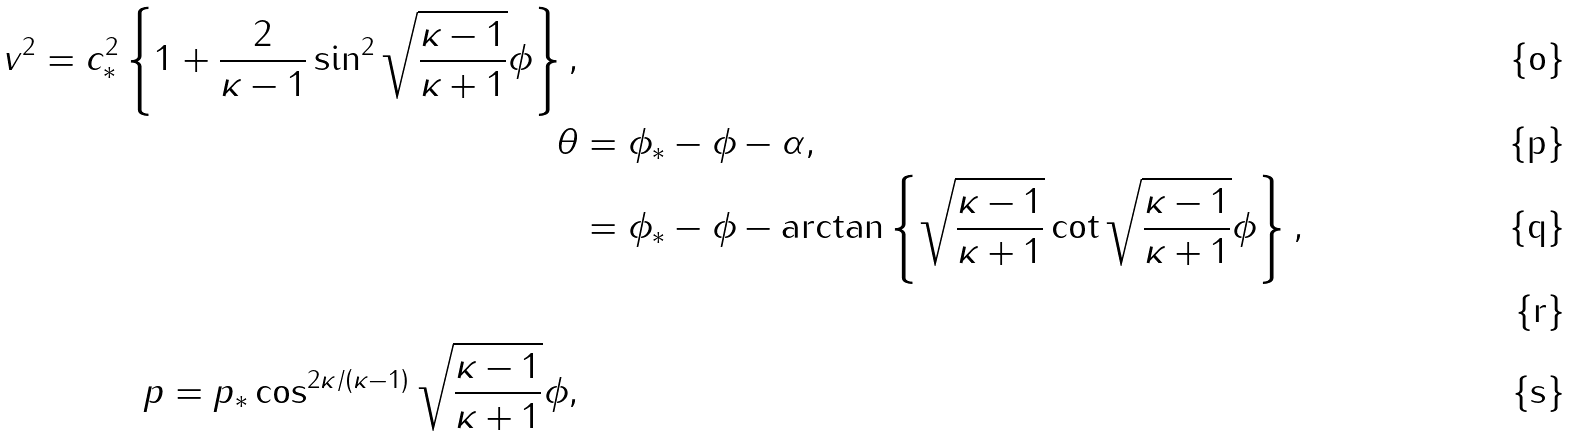Convert formula to latex. <formula><loc_0><loc_0><loc_500><loc_500>v ^ { 2 } = c _ { * } ^ { 2 } \left \{ 1 + \frac { 2 } { \kappa - 1 } \sin ^ { 2 } \sqrt { \frac { \kappa - 1 } { \kappa + 1 } } \phi \right \} , \\ \theta & = \phi _ { * } - \phi - \alpha , \\ & = \phi _ { * } - \phi - \arctan \left \{ \sqrt { \frac { \kappa - 1 } { \kappa + 1 } } \cot \sqrt { \frac { \kappa - 1 } { \kappa + 1 } } \phi \right \} , \\ \\ p = p _ { * } \cos ^ { 2 \kappa / \left ( \kappa - 1 \right ) } \sqrt { \frac { \kappa - 1 } { \kappa + 1 } } \phi ,</formula> 